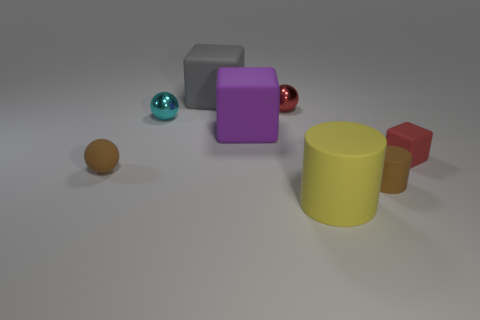Subtract all big cubes. How many cubes are left? 1 Add 1 small cylinders. How many objects exist? 9 Subtract all gray cubes. How many cubes are left? 2 Subtract 3 blocks. How many blocks are left? 0 Subtract all yellow objects. Subtract all small matte spheres. How many objects are left? 6 Add 1 things. How many things are left? 9 Add 1 yellow things. How many yellow things exist? 2 Subtract 0 green cylinders. How many objects are left? 8 Subtract all cubes. How many objects are left? 5 Subtract all gray blocks. Subtract all green cylinders. How many blocks are left? 2 